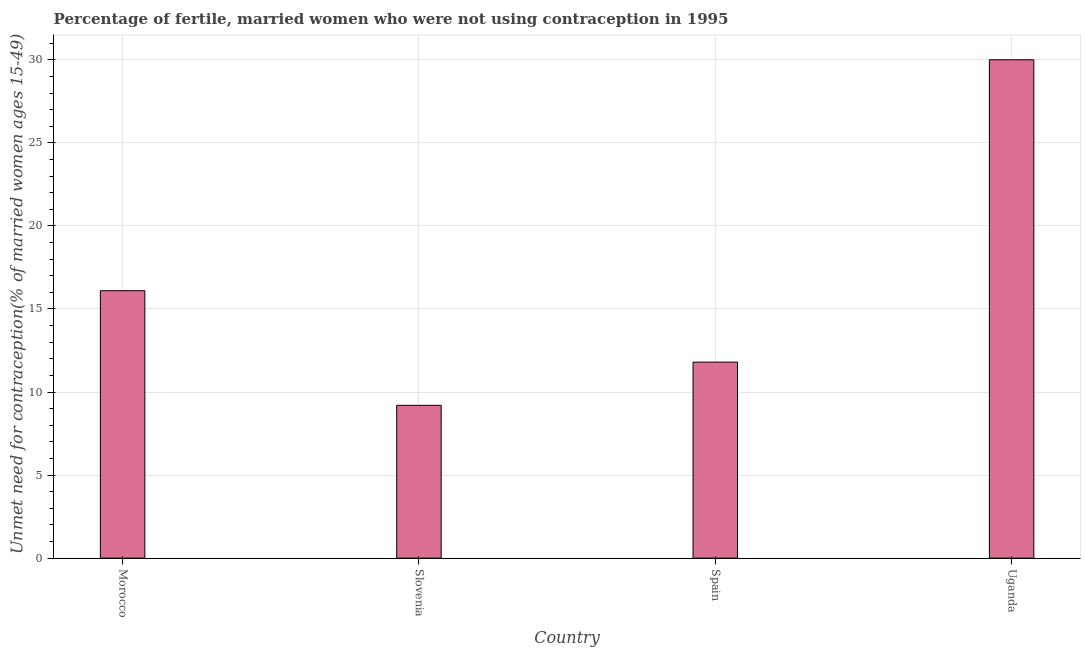What is the title of the graph?
Your response must be concise. Percentage of fertile, married women who were not using contraception in 1995. What is the label or title of the Y-axis?
Your answer should be very brief.  Unmet need for contraception(% of married women ages 15-49). Across all countries, what is the maximum number of married women who are not using contraception?
Your answer should be compact. 30. In which country was the number of married women who are not using contraception maximum?
Offer a terse response. Uganda. In which country was the number of married women who are not using contraception minimum?
Your answer should be very brief. Slovenia. What is the sum of the number of married women who are not using contraception?
Provide a short and direct response. 67.1. What is the average number of married women who are not using contraception per country?
Ensure brevity in your answer.  16.77. What is the median number of married women who are not using contraception?
Provide a short and direct response. 13.95. What is the ratio of the number of married women who are not using contraception in Slovenia to that in Uganda?
Provide a succinct answer. 0.31. Is the number of married women who are not using contraception in Morocco less than that in Slovenia?
Your response must be concise. No. Is the difference between the number of married women who are not using contraception in Morocco and Spain greater than the difference between any two countries?
Your answer should be very brief. No. What is the difference between the highest and the second highest number of married women who are not using contraception?
Ensure brevity in your answer.  13.9. What is the difference between the highest and the lowest number of married women who are not using contraception?
Ensure brevity in your answer.  20.8. Are all the bars in the graph horizontal?
Offer a terse response. No. What is the  Unmet need for contraception(% of married women ages 15-49) of Morocco?
Your answer should be compact. 16.1. What is the  Unmet need for contraception(% of married women ages 15-49) of Slovenia?
Ensure brevity in your answer.  9.2. What is the difference between the  Unmet need for contraception(% of married women ages 15-49) in Morocco and Slovenia?
Your response must be concise. 6.9. What is the difference between the  Unmet need for contraception(% of married women ages 15-49) in Morocco and Spain?
Your response must be concise. 4.3. What is the difference between the  Unmet need for contraception(% of married women ages 15-49) in Slovenia and Spain?
Provide a succinct answer. -2.6. What is the difference between the  Unmet need for contraception(% of married women ages 15-49) in Slovenia and Uganda?
Provide a short and direct response. -20.8. What is the difference between the  Unmet need for contraception(% of married women ages 15-49) in Spain and Uganda?
Make the answer very short. -18.2. What is the ratio of the  Unmet need for contraception(% of married women ages 15-49) in Morocco to that in Spain?
Your answer should be very brief. 1.36. What is the ratio of the  Unmet need for contraception(% of married women ages 15-49) in Morocco to that in Uganda?
Offer a terse response. 0.54. What is the ratio of the  Unmet need for contraception(% of married women ages 15-49) in Slovenia to that in Spain?
Ensure brevity in your answer.  0.78. What is the ratio of the  Unmet need for contraception(% of married women ages 15-49) in Slovenia to that in Uganda?
Your answer should be very brief. 0.31. What is the ratio of the  Unmet need for contraception(% of married women ages 15-49) in Spain to that in Uganda?
Offer a very short reply. 0.39. 